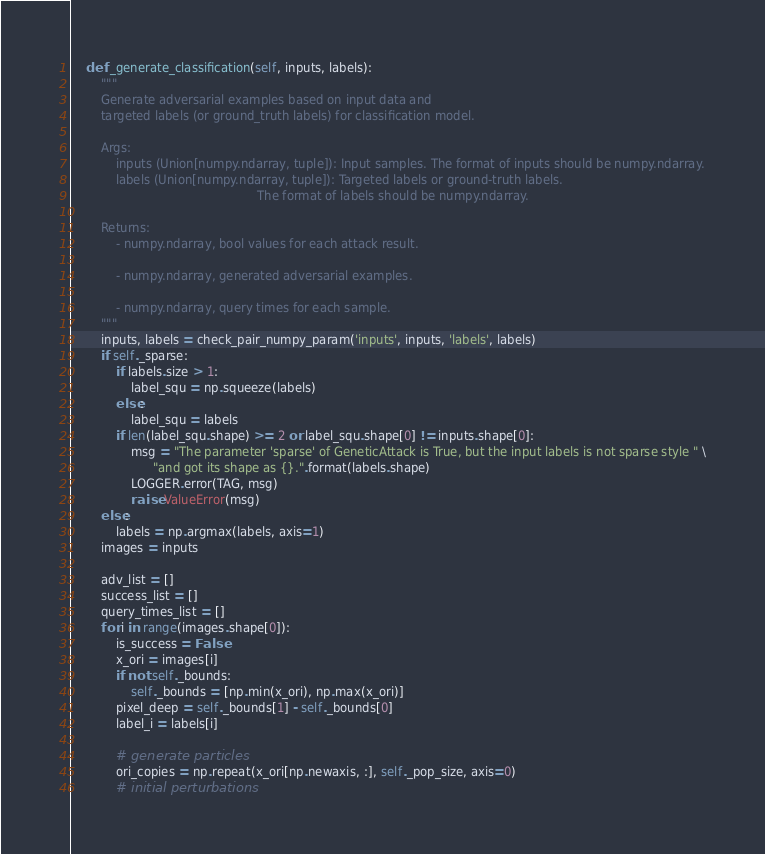<code> <loc_0><loc_0><loc_500><loc_500><_Python_>    def _generate_classification(self, inputs, labels):
        """
        Generate adversarial examples based on input data and
        targeted labels (or ground_truth labels) for classification model.

        Args:
            inputs (Union[numpy.ndarray, tuple]): Input samples. The format of inputs should be numpy.ndarray.
            labels (Union[numpy.ndarray, tuple]): Targeted labels or ground-truth labels.
                                                  The format of labels should be numpy.ndarray.

        Returns:
            - numpy.ndarray, bool values for each attack result.

            - numpy.ndarray, generated adversarial examples.

            - numpy.ndarray, query times for each sample.
        """
        inputs, labels = check_pair_numpy_param('inputs', inputs, 'labels', labels)
        if self._sparse:
            if labels.size > 1:
                label_squ = np.squeeze(labels)
            else:
                label_squ = labels
            if len(label_squ.shape) >= 2 or label_squ.shape[0] != inputs.shape[0]:
                msg = "The parameter 'sparse' of GeneticAttack is True, but the input labels is not sparse style " \
                      "and got its shape as {}.".format(labels.shape)
                LOGGER.error(TAG, msg)
                raise ValueError(msg)
        else:
            labels = np.argmax(labels, axis=1)
        images = inputs

        adv_list = []
        success_list = []
        query_times_list = []
        for i in range(images.shape[0]):
            is_success = False
            x_ori = images[i]
            if not self._bounds:
                self._bounds = [np.min(x_ori), np.max(x_ori)]
            pixel_deep = self._bounds[1] - self._bounds[0]
            label_i = labels[i]

            # generate particles
            ori_copies = np.repeat(x_ori[np.newaxis, :], self._pop_size, axis=0)
            # initial perturbations</code> 